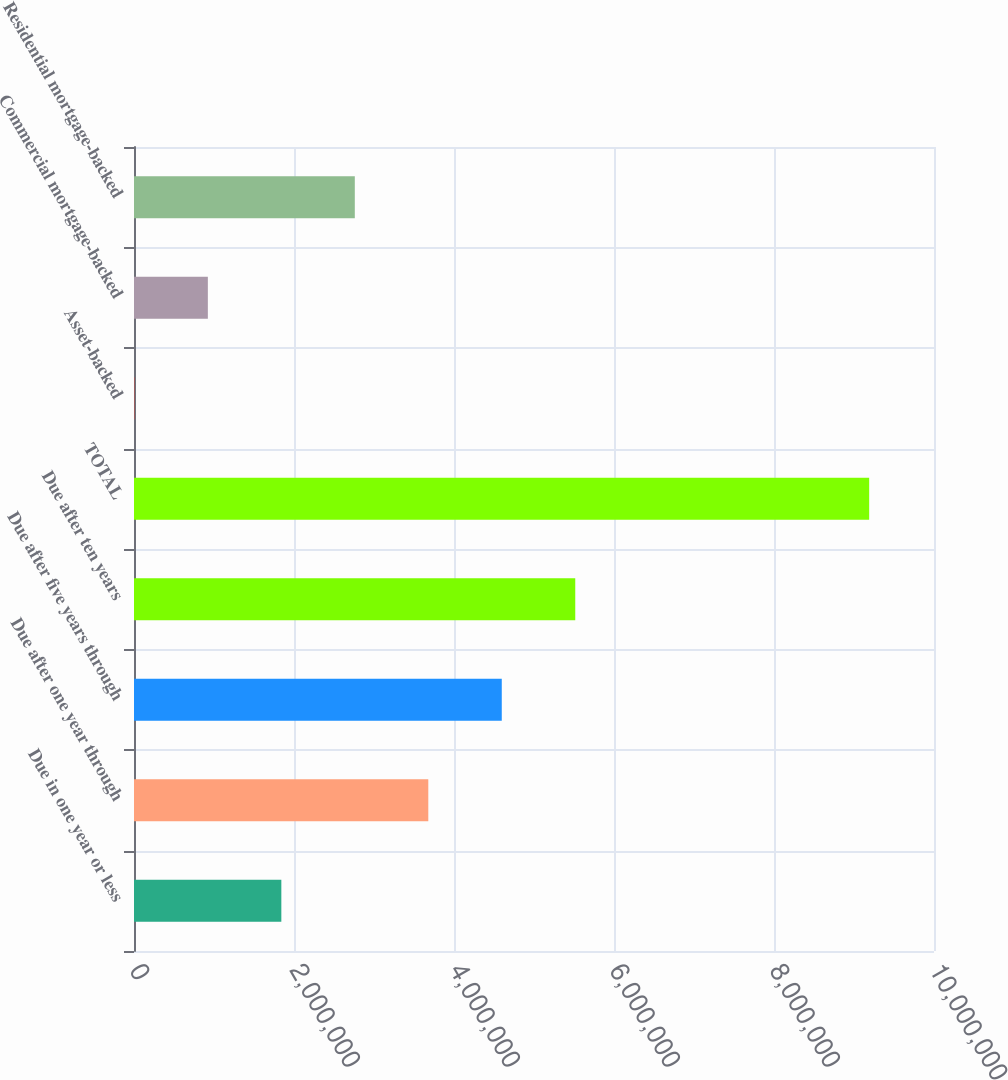Convert chart to OTSL. <chart><loc_0><loc_0><loc_500><loc_500><bar_chart><fcel>Due in one year or less<fcel>Due after one year through<fcel>Due after five years through<fcel>Due after ten years<fcel>TOTAL<fcel>Asset-backed<fcel>Commercial mortgage-backed<fcel>Residential mortgage-backed<nl><fcel>1.84166e+06<fcel>3.67865e+06<fcel>4.59715e+06<fcel>5.51564e+06<fcel>9.18963e+06<fcel>4662<fcel>923159<fcel>2.76015e+06<nl></chart> 